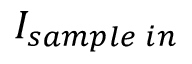Convert formula to latex. <formula><loc_0><loc_0><loc_500><loc_500>I _ { s a m p l e \, i n }</formula> 